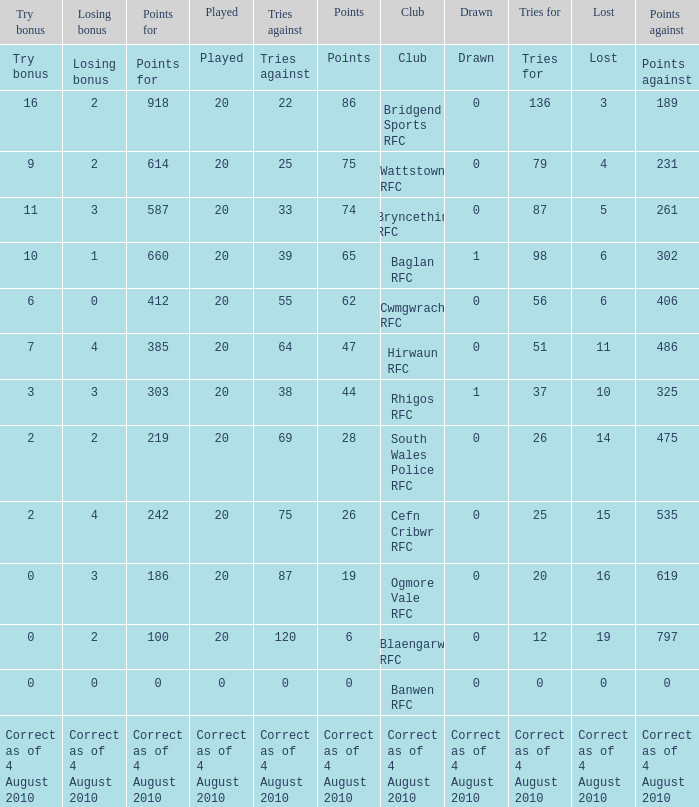What is drawn when the club is hirwaun rfc? 0.0. Parse the table in full. {'header': ['Try bonus', 'Losing bonus', 'Points for', 'Played', 'Tries against', 'Points', 'Club', 'Drawn', 'Tries for', 'Lost', 'Points against'], 'rows': [['Try bonus', 'Losing bonus', 'Points for', 'Played', 'Tries against', 'Points', 'Club', 'Drawn', 'Tries for', 'Lost', 'Points against'], ['16', '2', '918', '20', '22', '86', 'Bridgend Sports RFC', '0', '136', '3', '189'], ['9', '2', '614', '20', '25', '75', 'Wattstown RFC', '0', '79', '4', '231'], ['11', '3', '587', '20', '33', '74', 'Bryncethin RFC', '0', '87', '5', '261'], ['10', '1', '660', '20', '39', '65', 'Baglan RFC', '1', '98', '6', '302'], ['6', '0', '412', '20', '55', '62', 'Cwmgwrach RFC', '0', '56', '6', '406'], ['7', '4', '385', '20', '64', '47', 'Hirwaun RFC', '0', '51', '11', '486'], ['3', '3', '303', '20', '38', '44', 'Rhigos RFC', '1', '37', '10', '325'], ['2', '2', '219', '20', '69', '28', 'South Wales Police RFC', '0', '26', '14', '475'], ['2', '4', '242', '20', '75', '26', 'Cefn Cribwr RFC', '0', '25', '15', '535'], ['0', '3', '186', '20', '87', '19', 'Ogmore Vale RFC', '0', '20', '16', '619'], ['0', '2', '100', '20', '120', '6', 'Blaengarw RFC', '0', '12', '19', '797'], ['0', '0', '0', '0', '0', '0', 'Banwen RFC', '0', '0', '0', '0'], ['Correct as of 4 August 2010', 'Correct as of 4 August 2010', 'Correct as of 4 August 2010', 'Correct as of 4 August 2010', 'Correct as of 4 August 2010', 'Correct as of 4 August 2010', 'Correct as of 4 August 2010', 'Correct as of 4 August 2010', 'Correct as of 4 August 2010', 'Correct as of 4 August 2010', 'Correct as of 4 August 2010']]} 